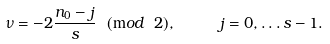Convert formula to latex. <formula><loc_0><loc_0><loc_500><loc_500>\nu = - 2 \frac { n _ { 0 } - j } { s } \ ( { \mathrm m o d } \ 2 ) , \quad \ j = 0 , \dots s - 1 .</formula> 